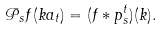Convert formula to latex. <formula><loc_0><loc_0><loc_500><loc_500>\mathcal { P } _ { s } f ( k a _ { t } ) = ( f \ast p ^ { t } _ { s } ) ( k ) .</formula> 